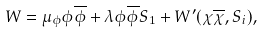Convert formula to latex. <formula><loc_0><loc_0><loc_500><loc_500>W = \mu _ { \phi } \phi \overline { \phi } + \lambda \phi \overline { \phi } S _ { 1 } + W ^ { \prime } ( \chi \overline { \chi } , S _ { i } ) ,</formula> 